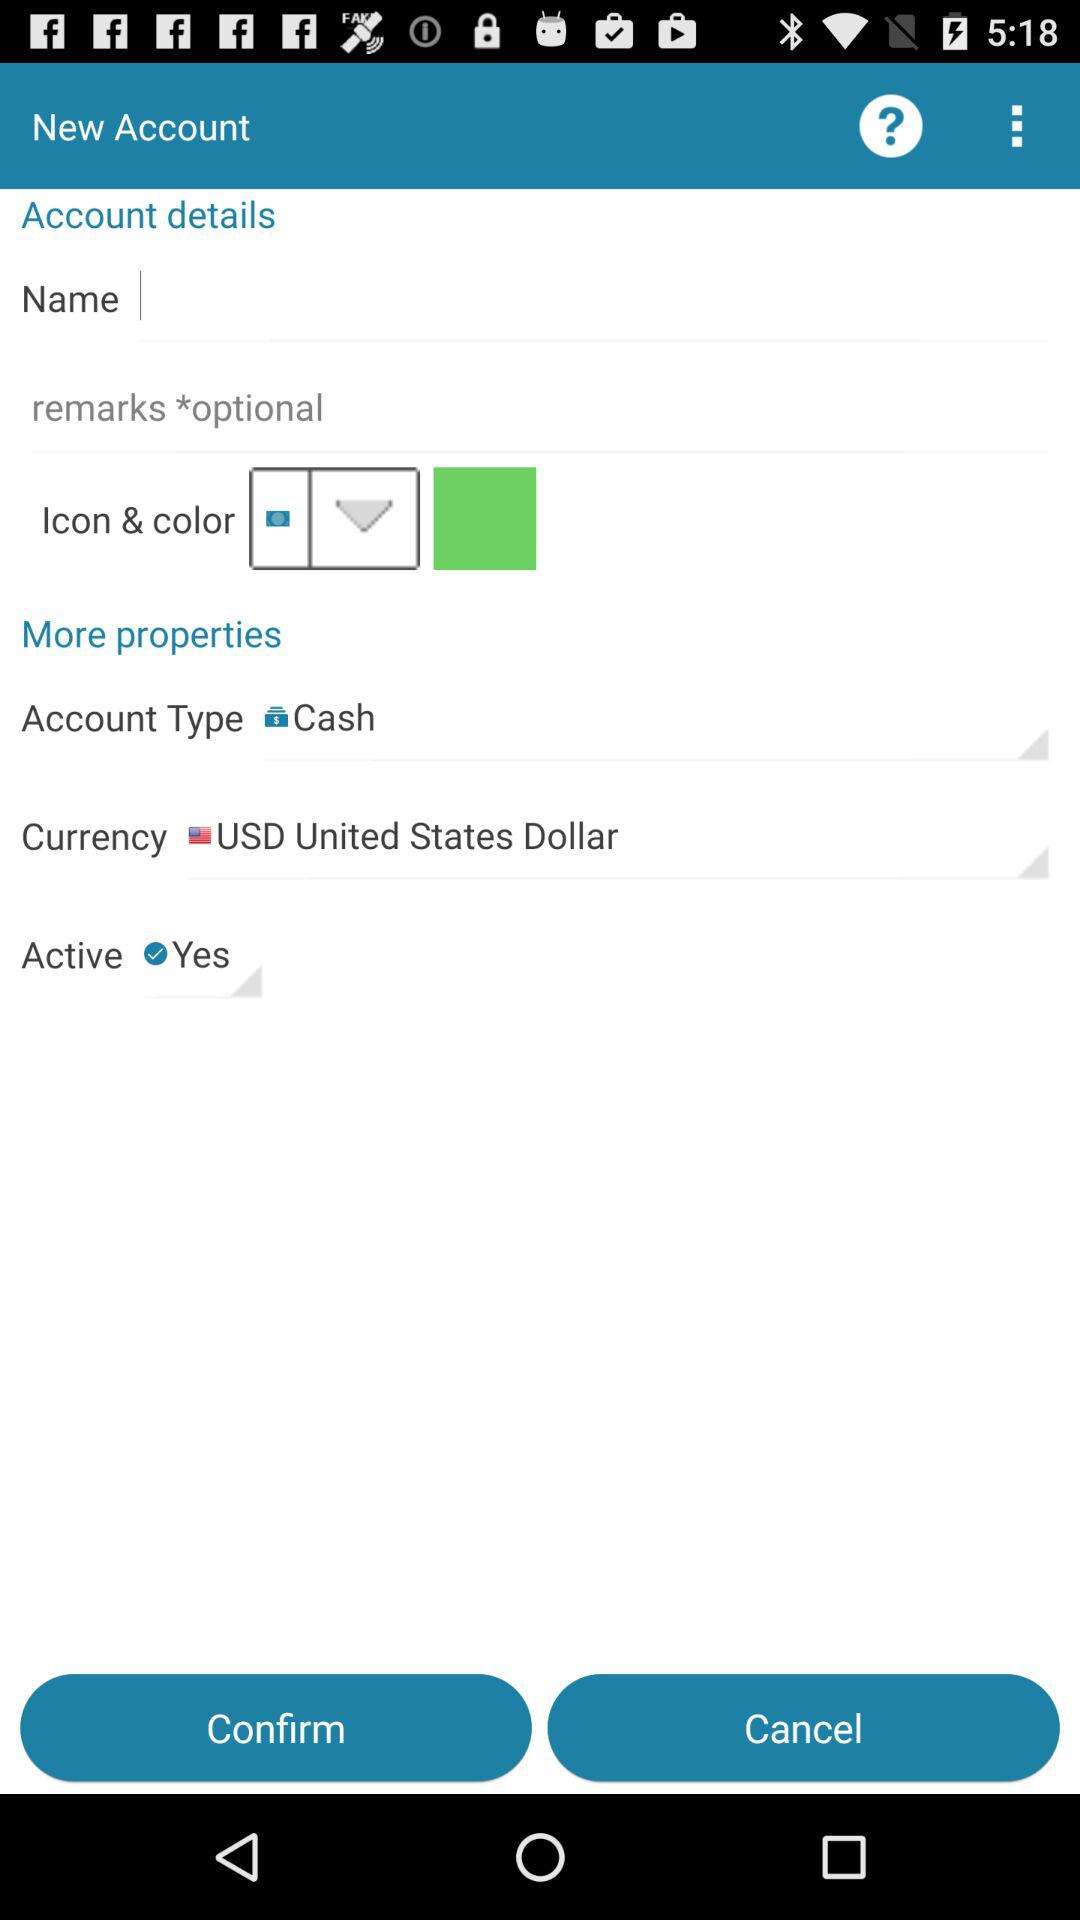What is the type of account? The type of account is cash. 